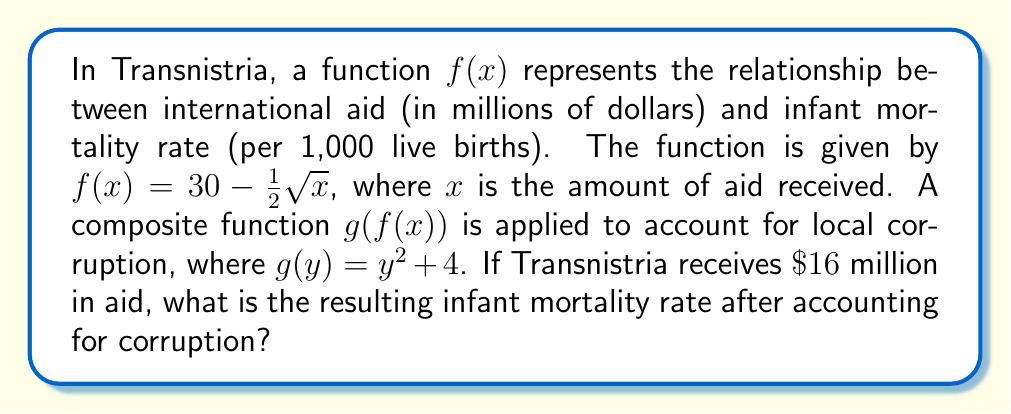Teach me how to tackle this problem. 1) First, we need to calculate $f(16)$:
   $f(16) = 30 - \frac{1}{2}\sqrt{16}$
   $= 30 - \frac{1}{2}(4)$
   $= 30 - 2 = 28$

2) Now, we apply the corruption function $g(y)$ to this result:
   $g(f(16)) = g(28)$
   $= 28^2 + 4$
   $= 784 + 4 = 788$

3) Therefore, the infant mortality rate after accounting for corruption is 788 per 1,000 live births.

This dramatic increase illustrates how corruption can severely impact the effectiveness of international aid on health outcomes in unrecognized territories like Transnistria.
Answer: 788 per 1,000 live births 